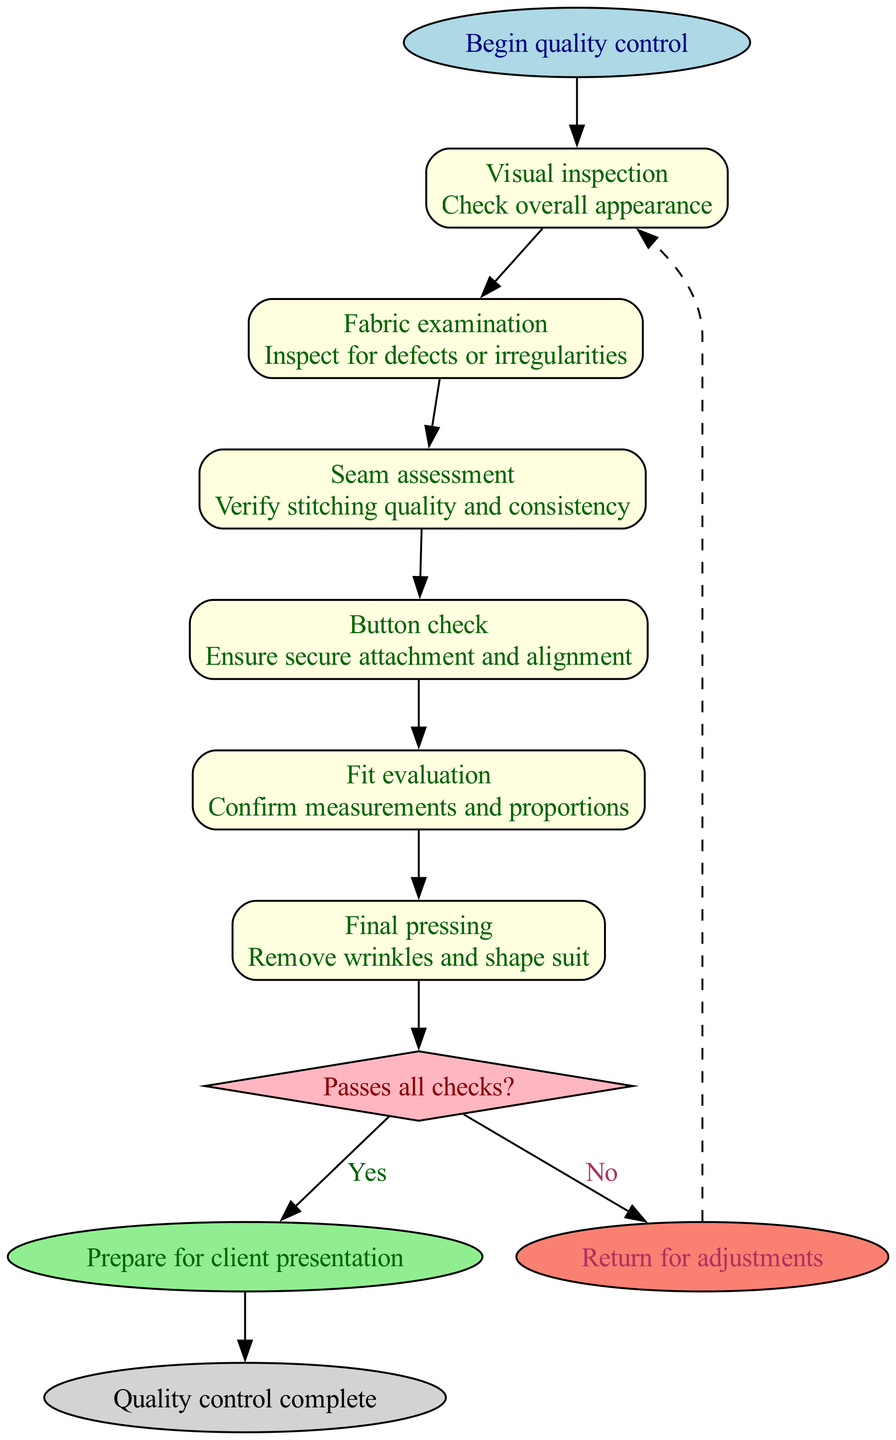What is the first step in the quality control process? The first step in the quality control process is "Visual inspection," where the overall appearance of the suit is checked.
Answer: Visual inspection How many steps are involved in the quality control process? There are six steps involved in the quality control process, including visual inspection, fabric examination, seam assessment, button check, fit evaluation, and final pressing.
Answer: Six What is checked during the "Button check" step? During the "Button check" step, the secure attachment and alignment of the buttons are ensured.
Answer: Secure attachment and alignment What happens if the suit passes all checks? If the suit passes all checks, the process leads to "Prepare for client presentation," indicating the suit is ready for the client.
Answer: Prepare for client presentation What is the final outcome of the quality control process? The final outcome of the quality control process is "Quality control complete," which indicates that the entire assessment has been concluded successfully.
Answer: Quality control complete Which step follows the decision point if the suit does not pass? If the suit does not pass the checks, the process returns to the first step for adjustments, following the decision point.
Answer: Return for adjustments What is the condition that leads to the decision node? The condition that leads to the decision node is "Passes all checks?" which determines whether the suit is ready for presentation or needs adjustments.
Answer: Passes all checks? What is the last step in the quality control process? The last step in the quality control process is "Quality control complete," which signifies the end of the process.
Answer: Quality control complete 